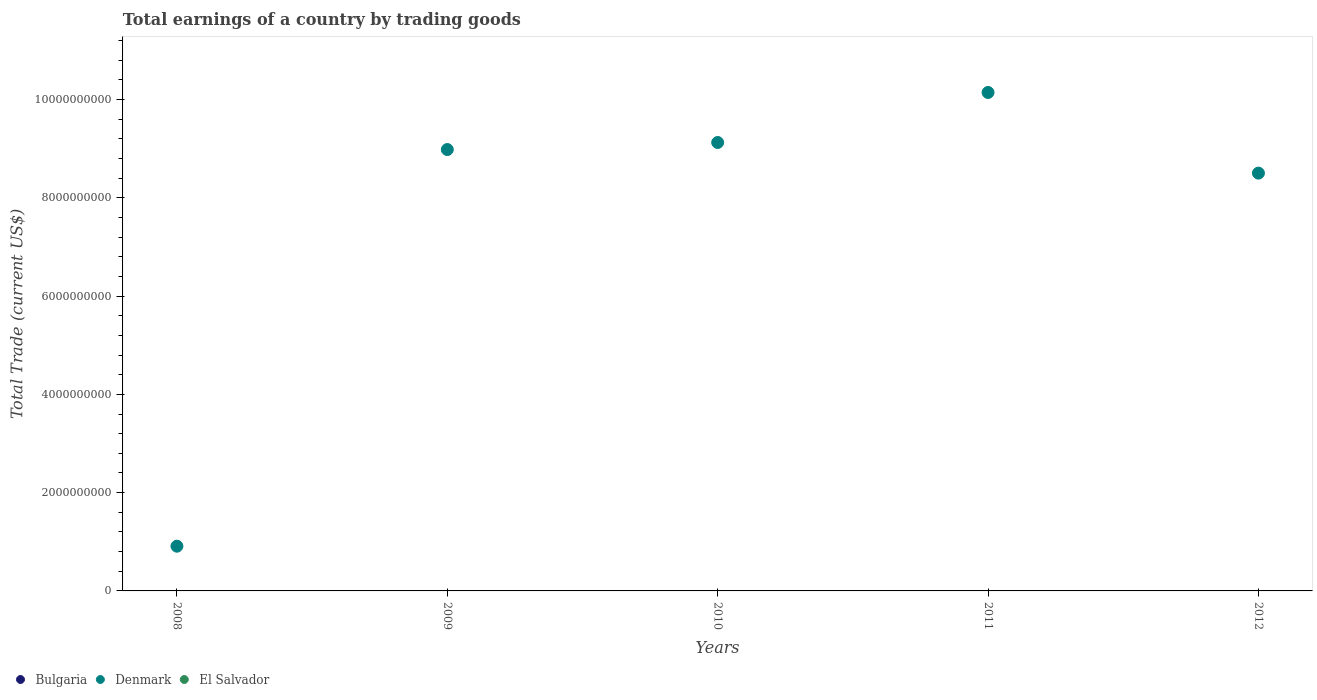What is the total earnings in Bulgaria in 2008?
Your answer should be compact. 0. Across all years, what is the maximum total earnings in Denmark?
Provide a succinct answer. 1.01e+1. In which year was the total earnings in Denmark maximum?
Ensure brevity in your answer.  2011. What is the total total earnings in El Salvador in the graph?
Offer a very short reply. 0. What is the difference between the total earnings in Denmark in 2010 and that in 2011?
Offer a terse response. -1.02e+09. What is the difference between the total earnings in El Salvador in 2009 and the total earnings in Denmark in 2012?
Your answer should be compact. -8.50e+09. What is the average total earnings in Bulgaria per year?
Make the answer very short. 0. What is the ratio of the total earnings in Denmark in 2008 to that in 2011?
Make the answer very short. 0.09. Is the total earnings in Denmark in 2009 less than that in 2012?
Your response must be concise. No. What is the difference between the highest and the second highest total earnings in Denmark?
Keep it short and to the point. 1.02e+09. What is the difference between the highest and the lowest total earnings in Denmark?
Offer a very short reply. 9.23e+09. Is the sum of the total earnings in Denmark in 2010 and 2011 greater than the maximum total earnings in El Salvador across all years?
Ensure brevity in your answer.  Yes. Is it the case that in every year, the sum of the total earnings in El Salvador and total earnings in Bulgaria  is greater than the total earnings in Denmark?
Offer a terse response. No. Does the total earnings in Bulgaria monotonically increase over the years?
Make the answer very short. No. Is the total earnings in Bulgaria strictly greater than the total earnings in Denmark over the years?
Your answer should be very brief. No. How many years are there in the graph?
Offer a terse response. 5. What is the difference between two consecutive major ticks on the Y-axis?
Your answer should be very brief. 2.00e+09. Does the graph contain grids?
Your response must be concise. No. Where does the legend appear in the graph?
Give a very brief answer. Bottom left. How many legend labels are there?
Your response must be concise. 3. How are the legend labels stacked?
Your answer should be very brief. Horizontal. What is the title of the graph?
Your answer should be compact. Total earnings of a country by trading goods. What is the label or title of the Y-axis?
Offer a terse response. Total Trade (current US$). What is the Total Trade (current US$) of Bulgaria in 2008?
Your answer should be compact. 0. What is the Total Trade (current US$) of Denmark in 2008?
Keep it short and to the point. 9.10e+08. What is the Total Trade (current US$) of El Salvador in 2008?
Keep it short and to the point. 0. What is the Total Trade (current US$) of Denmark in 2009?
Offer a very short reply. 8.98e+09. What is the Total Trade (current US$) of El Salvador in 2009?
Make the answer very short. 0. What is the Total Trade (current US$) of Bulgaria in 2010?
Provide a succinct answer. 0. What is the Total Trade (current US$) of Denmark in 2010?
Your response must be concise. 9.13e+09. What is the Total Trade (current US$) in El Salvador in 2010?
Keep it short and to the point. 0. What is the Total Trade (current US$) of Bulgaria in 2011?
Offer a very short reply. 0. What is the Total Trade (current US$) in Denmark in 2011?
Ensure brevity in your answer.  1.01e+1. What is the Total Trade (current US$) of El Salvador in 2011?
Your answer should be very brief. 0. What is the Total Trade (current US$) of Denmark in 2012?
Keep it short and to the point. 8.50e+09. Across all years, what is the maximum Total Trade (current US$) of Denmark?
Ensure brevity in your answer.  1.01e+1. Across all years, what is the minimum Total Trade (current US$) of Denmark?
Offer a terse response. 9.10e+08. What is the total Total Trade (current US$) in Bulgaria in the graph?
Offer a very short reply. 0. What is the total Total Trade (current US$) of Denmark in the graph?
Keep it short and to the point. 3.77e+1. What is the total Total Trade (current US$) in El Salvador in the graph?
Provide a short and direct response. 0. What is the difference between the Total Trade (current US$) in Denmark in 2008 and that in 2009?
Your answer should be compact. -8.07e+09. What is the difference between the Total Trade (current US$) in Denmark in 2008 and that in 2010?
Make the answer very short. -8.22e+09. What is the difference between the Total Trade (current US$) of Denmark in 2008 and that in 2011?
Your answer should be compact. -9.23e+09. What is the difference between the Total Trade (current US$) in Denmark in 2008 and that in 2012?
Ensure brevity in your answer.  -7.59e+09. What is the difference between the Total Trade (current US$) in Denmark in 2009 and that in 2010?
Offer a very short reply. -1.43e+08. What is the difference between the Total Trade (current US$) of Denmark in 2009 and that in 2011?
Your response must be concise. -1.16e+09. What is the difference between the Total Trade (current US$) of Denmark in 2009 and that in 2012?
Your answer should be very brief. 4.80e+08. What is the difference between the Total Trade (current US$) in Denmark in 2010 and that in 2011?
Offer a very short reply. -1.02e+09. What is the difference between the Total Trade (current US$) in Denmark in 2010 and that in 2012?
Keep it short and to the point. 6.23e+08. What is the difference between the Total Trade (current US$) of Denmark in 2011 and that in 2012?
Your answer should be very brief. 1.64e+09. What is the average Total Trade (current US$) in Bulgaria per year?
Give a very brief answer. 0. What is the average Total Trade (current US$) in Denmark per year?
Make the answer very short. 7.53e+09. What is the ratio of the Total Trade (current US$) in Denmark in 2008 to that in 2009?
Make the answer very short. 0.1. What is the ratio of the Total Trade (current US$) in Denmark in 2008 to that in 2010?
Ensure brevity in your answer.  0.1. What is the ratio of the Total Trade (current US$) in Denmark in 2008 to that in 2011?
Your answer should be very brief. 0.09. What is the ratio of the Total Trade (current US$) in Denmark in 2008 to that in 2012?
Provide a short and direct response. 0.11. What is the ratio of the Total Trade (current US$) in Denmark in 2009 to that in 2010?
Your answer should be very brief. 0.98. What is the ratio of the Total Trade (current US$) of Denmark in 2009 to that in 2011?
Your answer should be very brief. 0.89. What is the ratio of the Total Trade (current US$) in Denmark in 2009 to that in 2012?
Your response must be concise. 1.06. What is the ratio of the Total Trade (current US$) of Denmark in 2010 to that in 2011?
Your response must be concise. 0.9. What is the ratio of the Total Trade (current US$) of Denmark in 2010 to that in 2012?
Your response must be concise. 1.07. What is the ratio of the Total Trade (current US$) of Denmark in 2011 to that in 2012?
Provide a short and direct response. 1.19. What is the difference between the highest and the second highest Total Trade (current US$) of Denmark?
Provide a short and direct response. 1.02e+09. What is the difference between the highest and the lowest Total Trade (current US$) of Denmark?
Offer a terse response. 9.23e+09. 